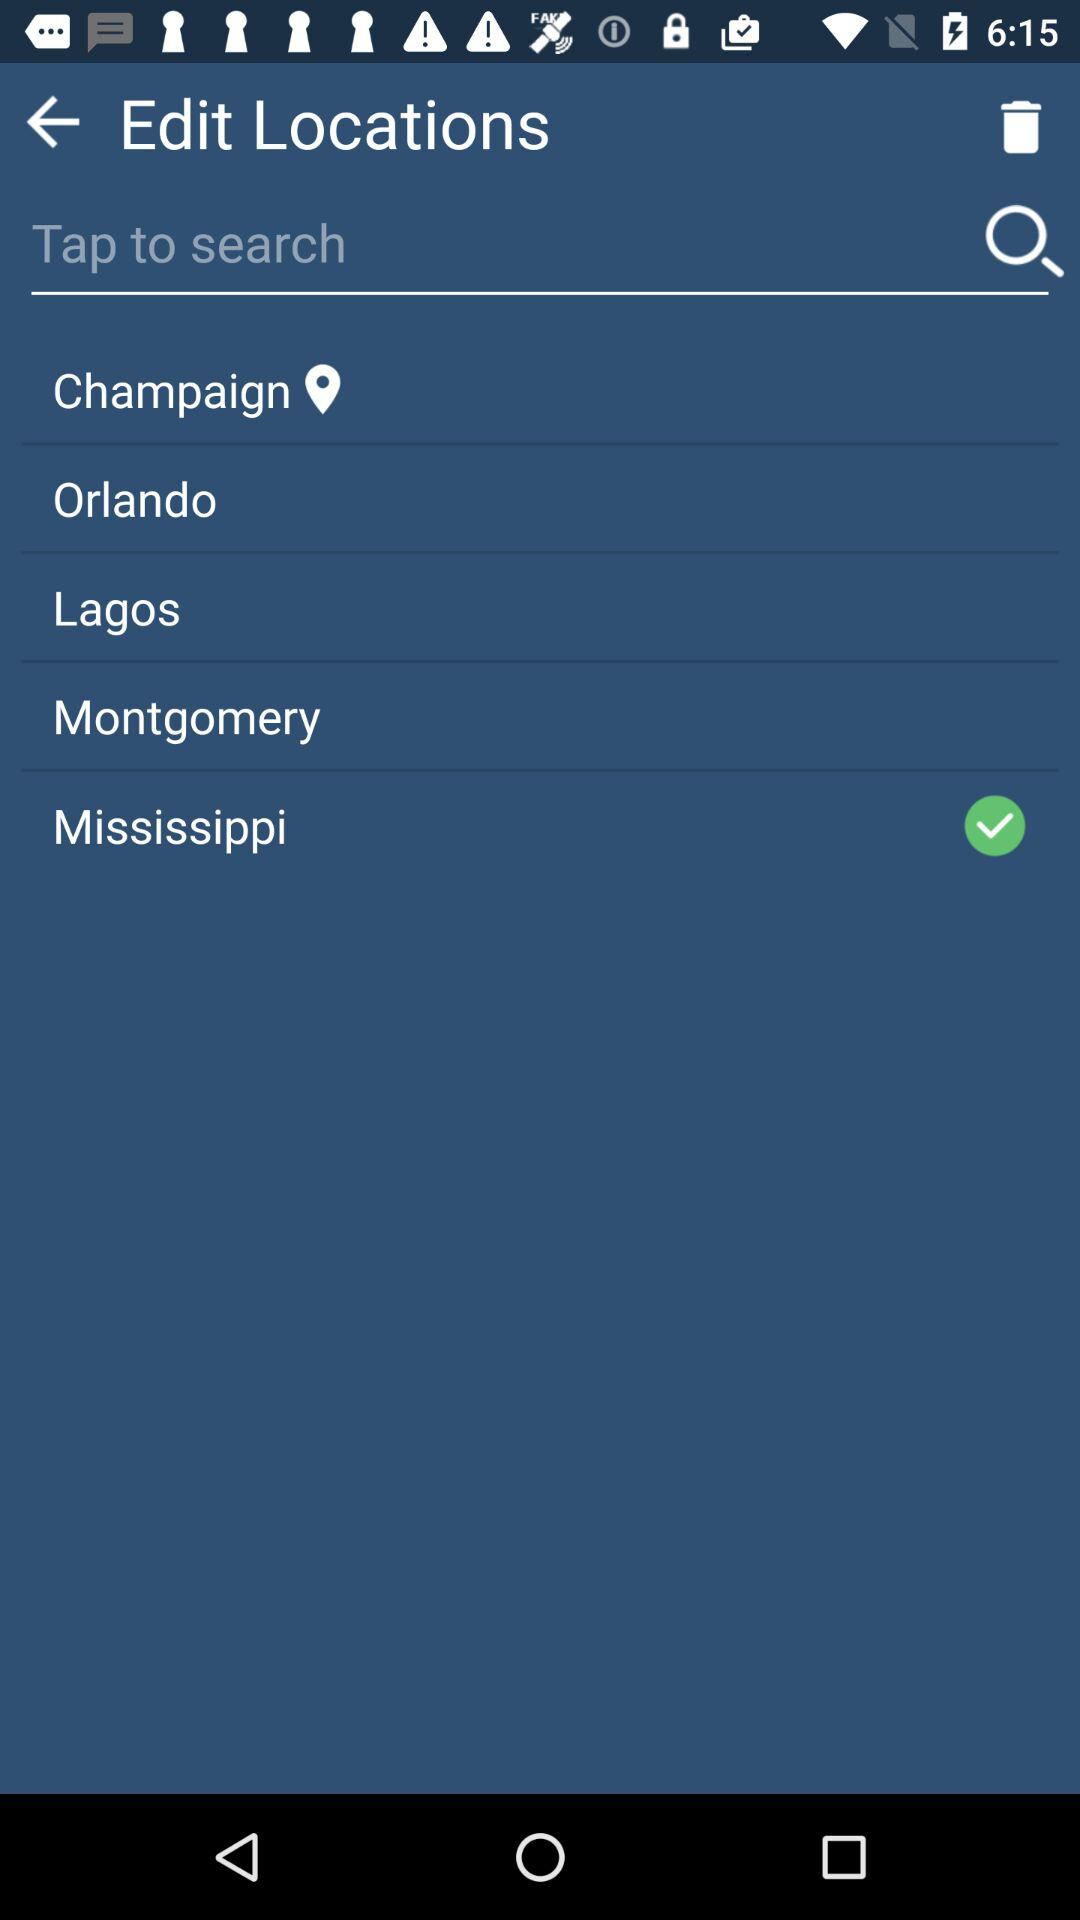How many locations are checked in the edit locations screen?
Answer the question using a single word or phrase. 1 